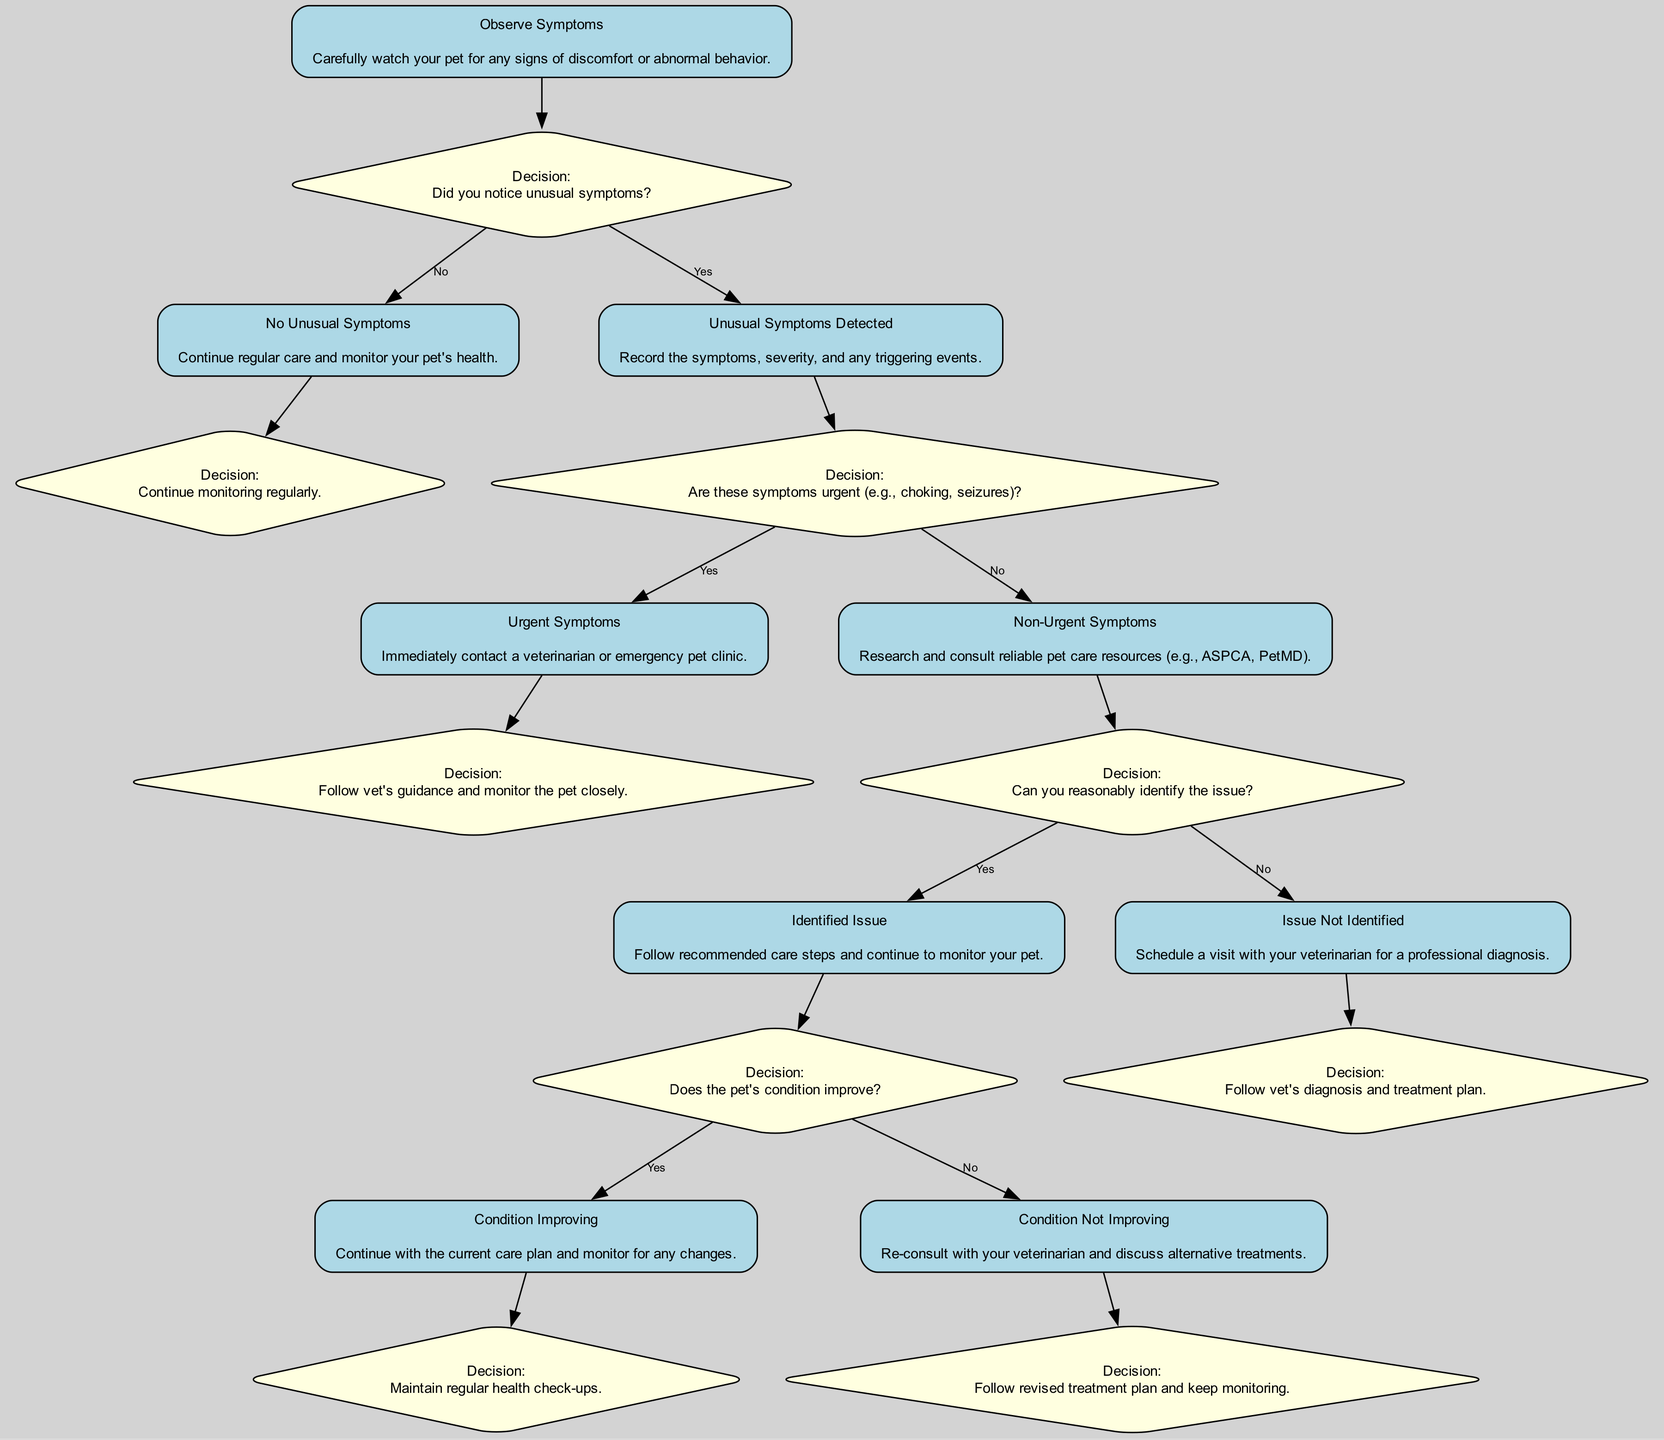What is the first step in the process? The first step in the process is "Observe Symptoms," which involves watching the pet for any signs of discomfort or abnormal behavior. This can be found in the node corresponding to step 1 in the diagram.
Answer: Observe Symptoms How many total decision points are in the diagram? There are five decision points present in the diagram. These are indicated by the diamond-shaped nodes that lead to various paths based on the answers "Yes" or "No."
Answer: Five What happens if unusual symptoms are detected? If unusual symptoms are detected, the next action is to record the symptoms, severity, and any triggering events. This information is the output from step 2b in the diagram leading to the decision point concerning urgency.
Answer: Record the symptoms If the pet's condition improves, what is the next action? If the pet's condition improves, the next action is to continue with the current care plan and monitor for any changes. This follows from the decision point in step 4a.
Answer: Continue with the current care plan What are the two outcomes when urgent symptoms are present? When urgent symptoms are present, the two outcomes are either contacting a veterinarian or an emergency pet clinic; or following the veterinarian's guidance and monitoring the pet closely afterwards. This comes from step 3a of the diagram.
Answer: Contact a veterinarian or emergency pet clinic What should you do if non-urgent symptoms are observed and the issue is not identified? If non-urgent symptoms are observed and the issue is not identified, the next step is to schedule a visit with the veterinarian for a professional diagnosis. This follows from step 4b in the diagram.
Answer: Schedule a visit with your veterinarian What leads to a decision about whether the pet's condition is improving? The decision about whether the pet's condition is improving is based on the output from step 4a, where the previous care steps are followed, leading to the monitoring of the pet. If there is improvement, the process continues from step 5a.
Answer: Follow recommended care steps How does the diagram guide you if your pet shows no unusual symptoms? If your pet shows no unusual symptoms, the diagram guides you to continue regular care and monitor your pet's health. This is described in step 2a, which follows from the initial decision point.
Answer: Continue regular care and monitor health What is the next step after identifying an issue? After identifying an issue, the next step is to follow the recommended care steps and continue to monitor the pet's condition. This follows from step 4a in the decision-making process.
Answer: Follow recommended care steps 